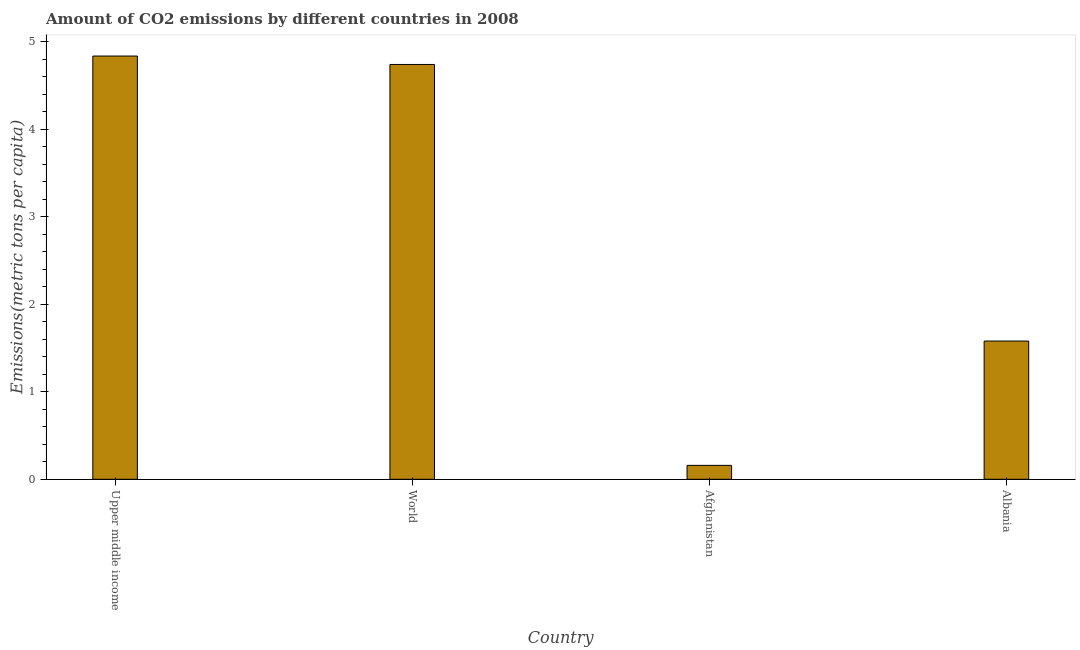Does the graph contain grids?
Provide a short and direct response. No. What is the title of the graph?
Ensure brevity in your answer.  Amount of CO2 emissions by different countries in 2008. What is the label or title of the Y-axis?
Ensure brevity in your answer.  Emissions(metric tons per capita). What is the amount of co2 emissions in Albania?
Your response must be concise. 1.58. Across all countries, what is the maximum amount of co2 emissions?
Make the answer very short. 4.84. Across all countries, what is the minimum amount of co2 emissions?
Give a very brief answer. 0.16. In which country was the amount of co2 emissions maximum?
Offer a terse response. Upper middle income. In which country was the amount of co2 emissions minimum?
Keep it short and to the point. Afghanistan. What is the sum of the amount of co2 emissions?
Your answer should be very brief. 11.32. What is the difference between the amount of co2 emissions in Afghanistan and World?
Give a very brief answer. -4.58. What is the average amount of co2 emissions per country?
Provide a short and direct response. 2.83. What is the median amount of co2 emissions?
Your answer should be very brief. 3.16. In how many countries, is the amount of co2 emissions greater than 0.2 metric tons per capita?
Provide a succinct answer. 3. What is the ratio of the amount of co2 emissions in Afghanistan to that in Albania?
Give a very brief answer. 0.1. Is the amount of co2 emissions in Afghanistan less than that in World?
Your response must be concise. Yes. What is the difference between the highest and the second highest amount of co2 emissions?
Offer a very short reply. 0.1. What is the difference between the highest and the lowest amount of co2 emissions?
Offer a terse response. 4.68. In how many countries, is the amount of co2 emissions greater than the average amount of co2 emissions taken over all countries?
Provide a short and direct response. 2. How many bars are there?
Offer a very short reply. 4. Are the values on the major ticks of Y-axis written in scientific E-notation?
Your response must be concise. No. What is the Emissions(metric tons per capita) in Upper middle income?
Make the answer very short. 4.84. What is the Emissions(metric tons per capita) of World?
Make the answer very short. 4.74. What is the Emissions(metric tons per capita) in Afghanistan?
Provide a succinct answer. 0.16. What is the Emissions(metric tons per capita) of Albania?
Ensure brevity in your answer.  1.58. What is the difference between the Emissions(metric tons per capita) in Upper middle income and World?
Provide a succinct answer. 0.1. What is the difference between the Emissions(metric tons per capita) in Upper middle income and Afghanistan?
Provide a succinct answer. 4.68. What is the difference between the Emissions(metric tons per capita) in Upper middle income and Albania?
Your answer should be very brief. 3.26. What is the difference between the Emissions(metric tons per capita) in World and Afghanistan?
Offer a terse response. 4.58. What is the difference between the Emissions(metric tons per capita) in World and Albania?
Your answer should be very brief. 3.16. What is the difference between the Emissions(metric tons per capita) in Afghanistan and Albania?
Your answer should be compact. -1.42. What is the ratio of the Emissions(metric tons per capita) in Upper middle income to that in World?
Your response must be concise. 1.02. What is the ratio of the Emissions(metric tons per capita) in Upper middle income to that in Afghanistan?
Give a very brief answer. 30.44. What is the ratio of the Emissions(metric tons per capita) in Upper middle income to that in Albania?
Offer a terse response. 3.06. What is the ratio of the Emissions(metric tons per capita) in World to that in Afghanistan?
Provide a succinct answer. 29.83. What is the ratio of the Emissions(metric tons per capita) in World to that in Albania?
Offer a terse response. 3. What is the ratio of the Emissions(metric tons per capita) in Afghanistan to that in Albania?
Offer a very short reply. 0.1. 